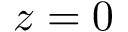<formula> <loc_0><loc_0><loc_500><loc_500>z = 0</formula> 